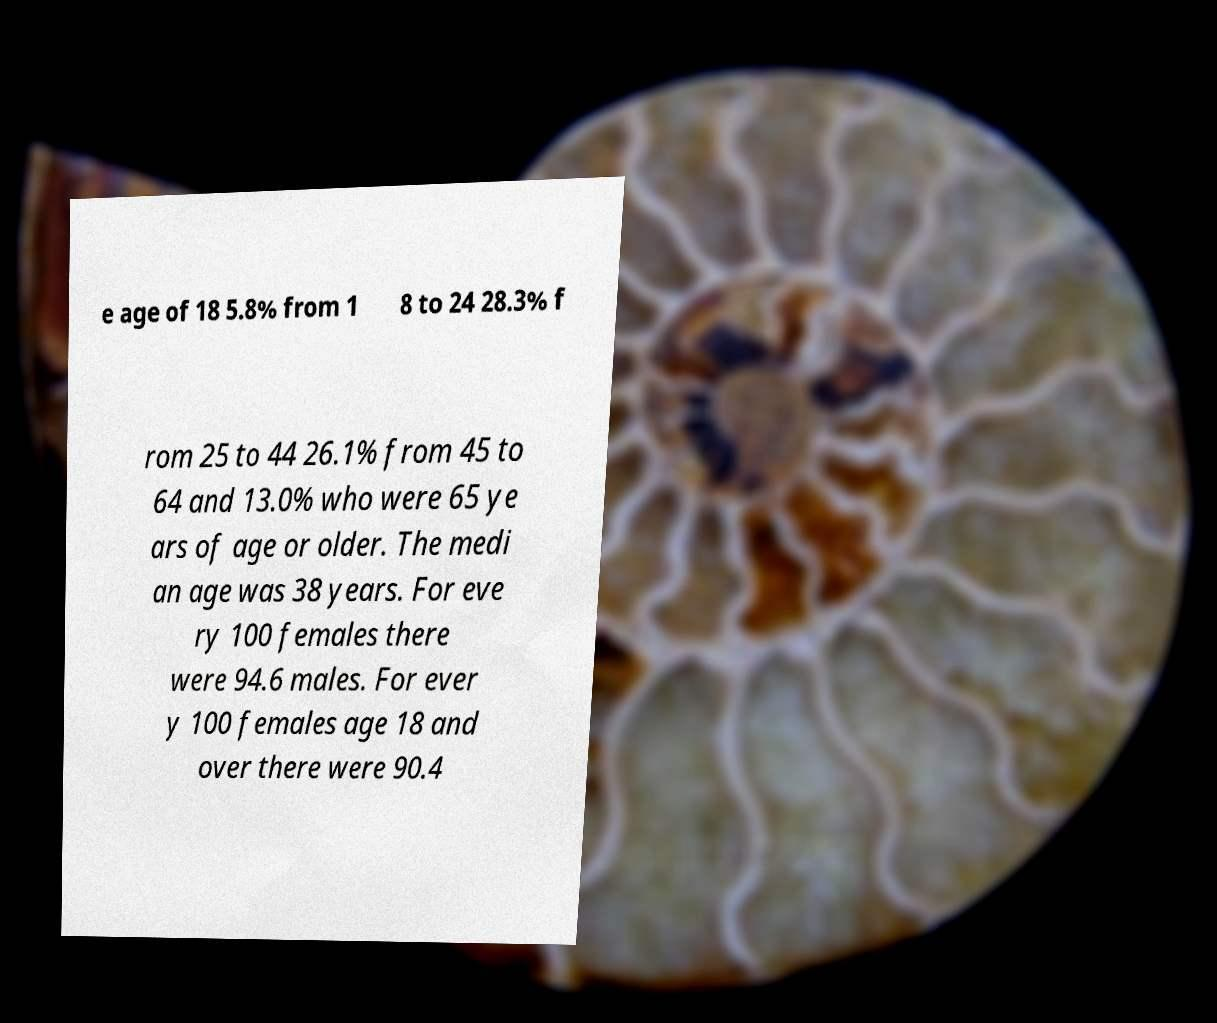Please identify and transcribe the text found in this image. e age of 18 5.8% from 1 8 to 24 28.3% f rom 25 to 44 26.1% from 45 to 64 and 13.0% who were 65 ye ars of age or older. The medi an age was 38 years. For eve ry 100 females there were 94.6 males. For ever y 100 females age 18 and over there were 90.4 